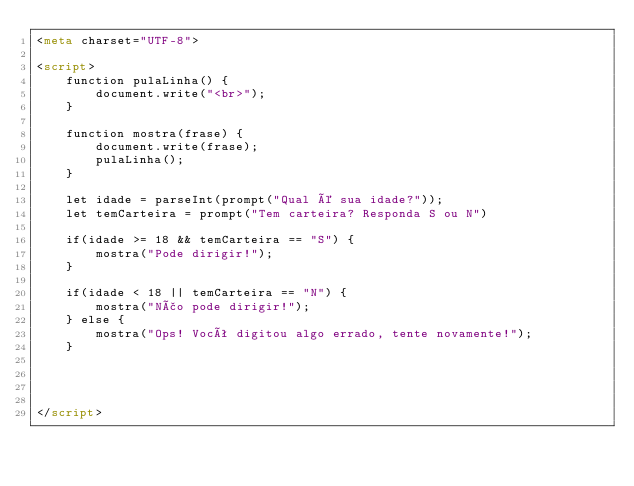Convert code to text. <code><loc_0><loc_0><loc_500><loc_500><_HTML_><meta charset="UTF-8">

<script>
    function pulaLinha() {
        document.write("<br>");
    }

    function mostra(frase) {
        document.write(frase);
        pulaLinha();
    }

    let idade = parseInt(prompt("Qual é sua idade?"));
    let temCarteira = prompt("Tem carteira? Responda S ou N")

    if(idade >= 18 && temCarteira == "S") {
        mostra("Pode dirigir!");
    }

    if(idade < 18 || temCarteira == "N") {
        mostra("Não pode dirigir!");
    } else {
        mostra("Ops! Você digitou algo errado, tente novamente!");
    }


    

</script></code> 